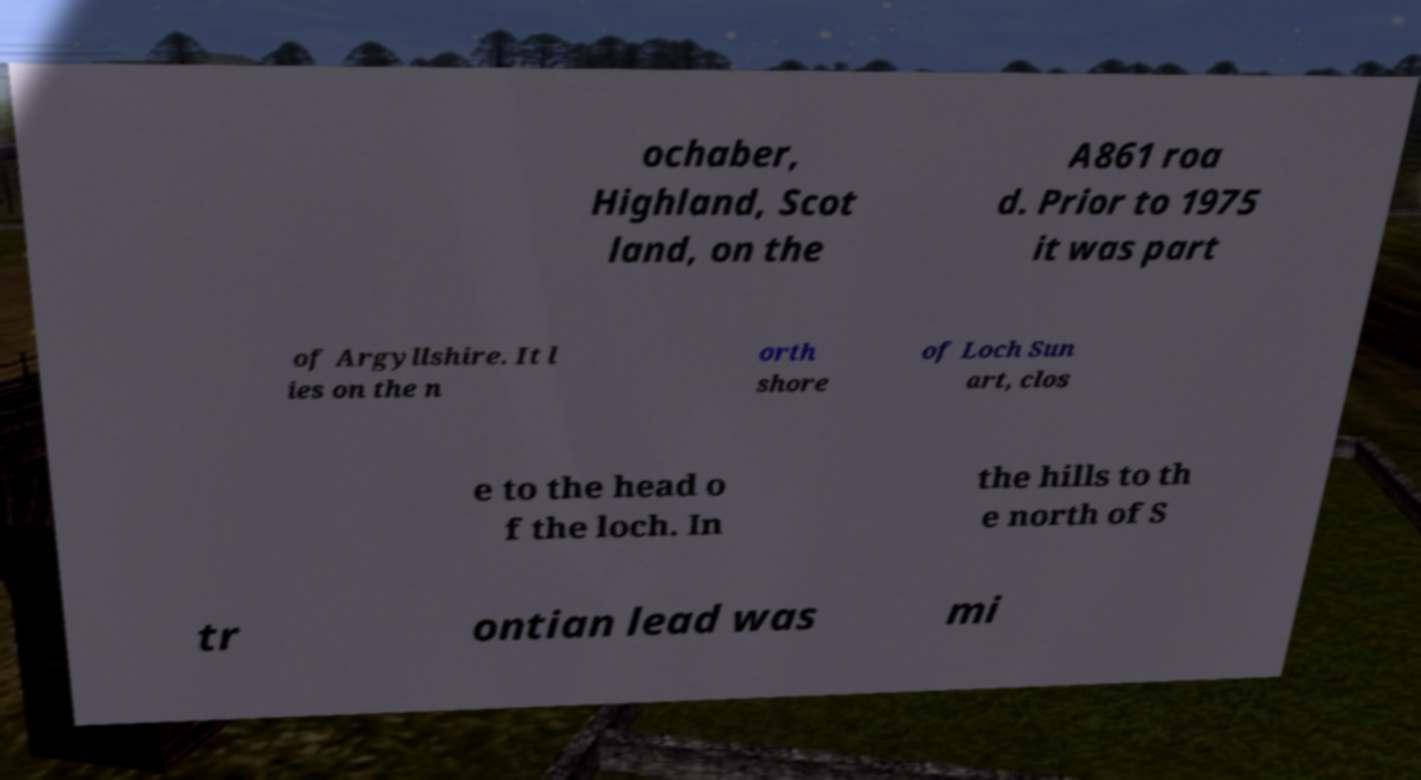I need the written content from this picture converted into text. Can you do that? ochaber, Highland, Scot land, on the A861 roa d. Prior to 1975 it was part of Argyllshire. It l ies on the n orth shore of Loch Sun art, clos e to the head o f the loch. In the hills to th e north of S tr ontian lead was mi 